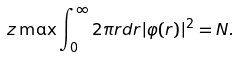Convert formula to latex. <formula><loc_0><loc_0><loc_500><loc_500>\ z \max \int _ { 0 } ^ { \infty } 2 \pi r d r | \varphi ( r ) | ^ { 2 } = N .</formula> 